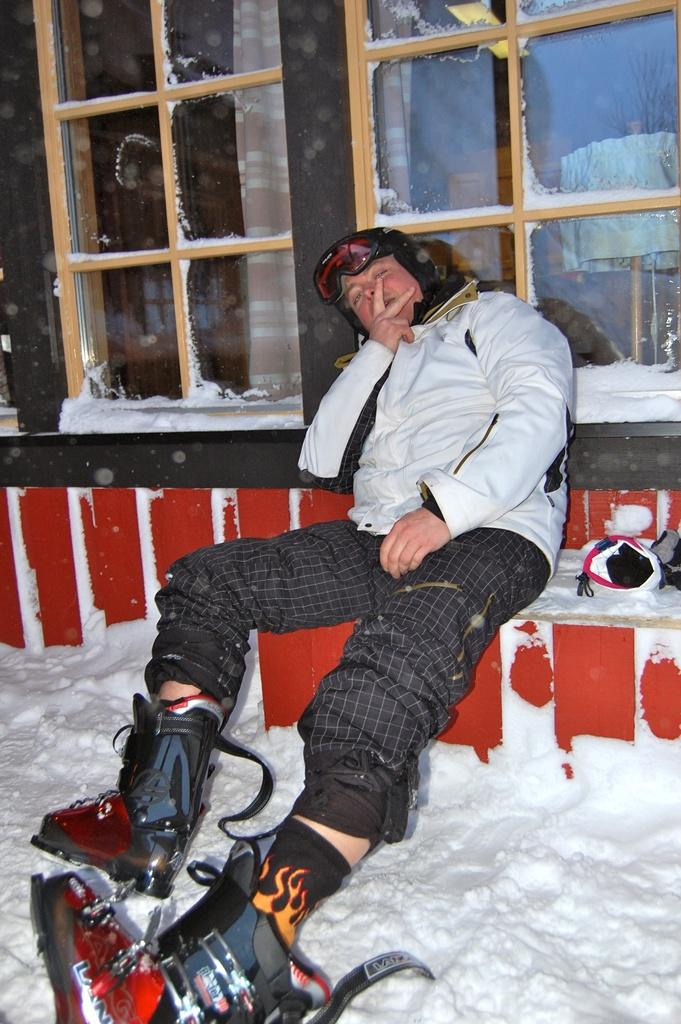What is the person in the image doing? The person is sitting on a platform. What is the condition of the platform? The platform is covered in snow. What objects can be seen in the background of the image? There are glasses in the background of the image. Where is the mine located in the image? There is no mine present in the image. 